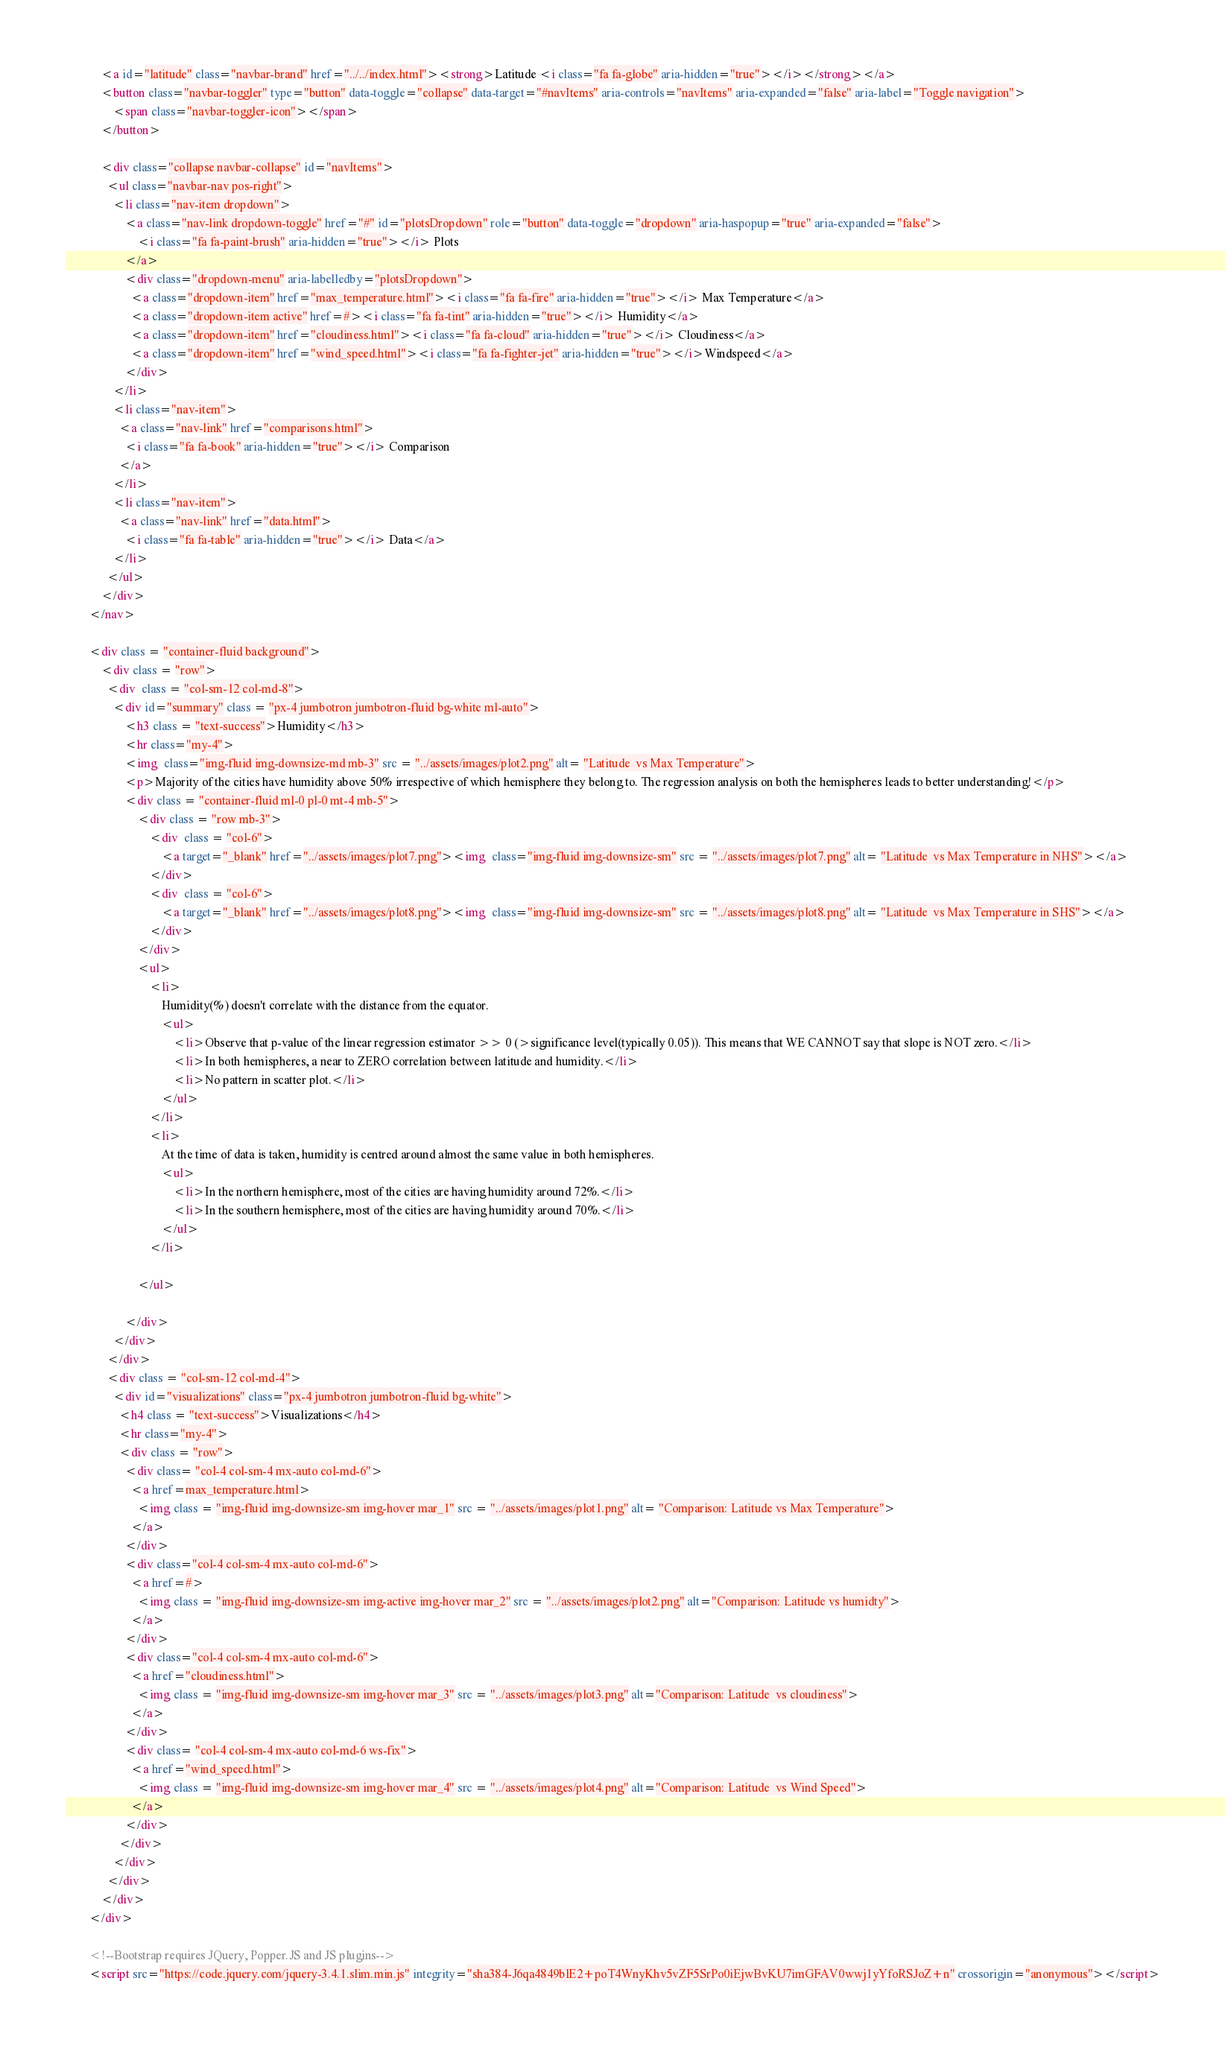<code> <loc_0><loc_0><loc_500><loc_500><_HTML_>            <a id="latitude" class="navbar-brand" href="../../index.html"><strong>Latitude <i class="fa fa-globe" aria-hidden="true"></i></strong></a>
            <button class="navbar-toggler" type="button" data-toggle="collapse" data-target="#navItems" aria-controls="navItems" aria-expanded="false" aria-label="Toggle navigation">
                <span class="navbar-toggler-icon"></span>
            </button>
          
            <div class="collapse navbar-collapse" id="navItems">
              <ul class="navbar-nav pos-right">
                <li class="nav-item dropdown">
                    <a class="nav-link dropdown-toggle" href="#" id="plotsDropdown" role="button" data-toggle="dropdown" aria-haspopup="true" aria-expanded="false">
                        <i class="fa fa-paint-brush" aria-hidden="true"></i> Plots
                    </a>
                    <div class="dropdown-menu" aria-labelledby="plotsDropdown">
                      <a class="dropdown-item" href="max_temperature.html"><i class="fa fa-fire" aria-hidden="true"></i> Max Temperature</a>
                      <a class="dropdown-item active" href=#><i class="fa fa-tint" aria-hidden="true"></i> Humidity</a>
                      <a class="dropdown-item" href="cloudiness.html"><i class="fa fa-cloud" aria-hidden="true"></i> Cloudiness</a>
                      <a class="dropdown-item" href="wind_speed.html"><i class="fa fa-fighter-jet" aria-hidden="true"></i>Windspeed</a>
                    </div>
                </li>
                <li class="nav-item">
                  <a class="nav-link" href="comparisons.html">
                    <i class="fa fa-book" aria-hidden="true"></i> Comparison
                  </a>
                </li>
                <li class="nav-item">
                  <a class="nav-link" href="data.html">
                    <i class="fa fa-table" aria-hidden="true"></i> Data</a>
                </li>
              </ul>
            </div>
        </nav>

        <div class = "container-fluid background">
            <div class = "row">
              <div  class = "col-sm-12 col-md-8">
                <div id="summary" class = "px-4 jumbotron jumbotron-fluid bg-white ml-auto">
                    <h3 class = "text-success">Humidity</h3>
                    <hr class="my-4">
                    <img  class="img-fluid img-downsize-md mb-3" src = "../assets/images/plot2.png" alt= "Latitude  vs Max Temperature"> 
                    <p>Majority of the cities have humidity above 50% irrespective of which hemisphere they belong to. The regression analysis on both the hemispheres leads to better understanding!</p>
                    <div class = "container-fluid ml-0 pl-0 mt-4 mb-5">
                        <div class = "row mb-3">
                            <div  class = "col-6">
                                <a target="_blank" href="../assets/images/plot7.png"><img  class="img-fluid img-downsize-sm" src = "../assets/images/plot7.png" alt= "Latitude  vs Max Temperature in NHS"></a> 
                            </div>
                            <div  class = "col-6">
                                <a target="_blank" href="../assets/images/plot8.png"><img  class="img-fluid img-downsize-sm" src = "../assets/images/plot8.png" alt= "Latitude  vs Max Temperature in SHS"></a>
                            </div>
                        </div>
                        <ul>
                            <li>
                                Humidity(%) doesn't correlate with the distance from the equator. 
                                <ul>
                                    <li>Observe that p-value of the linear regression estimator >> 0 (>significance level(typically 0.05)). This means that WE CANNOT say that slope is NOT zero.</li>
                                    <li>In both hemispheres, a near to ZERO correlation between latitude and humidity.</li>
                                    <li>No pattern in scatter plot.</li>
                                </ul>
                            </li>
                            <li>
                                At the time of data is taken, humidity is centred around almost the same value in both hemispheres.
                                <ul>
                                    <li>In the northern hemisphere, most of the cities are having humidity around 72%.</li>
                                    <li>In the southern hemisphere, most of the cities are having humidity around 70%.</li>
                                </ul>
                            </li>

                        </ul>
                        
                    </div>
                </div>
              </div>
              <div class = "col-sm-12 col-md-4">
                <div id="visualizations" class="px-4 jumbotron jumbotron-fluid bg-white">
                  <h4 class = "text-success">Visualizations</h4>
                  <hr class="my-4">
                  <div class = "row">
                    <div class= "col-4 col-sm-4 mx-auto col-md-6">
                      <a href=max_temperature.html>
                        <img class = "img-fluid img-downsize-sm img-hover mar_1" src = "../assets/images/plot1.png" alt= "Comparison: Latitude vs Max Temperature"> 
                      </a>
                    </div>
                    <div class="col-4 col-sm-4 mx-auto col-md-6">
                      <a href=#>
                        <img class = "img-fluid img-downsize-sm img-active img-hover mar_2" src = "../assets/images/plot2.png" alt="Comparison: Latitude vs humidty">
                      </a>
                    </div>
                    <div class="col-4 col-sm-4 mx-auto col-md-6">
                      <a href="cloudiness.html">
                        <img class = "img-fluid img-downsize-sm img-hover mar_3" src = "../assets/images/plot3.png" alt="Comparison: Latitude  vs cloudiness">  
                      </a>
                    </div>
                    <div class= "col-4 col-sm-4 mx-auto col-md-6 ws-fix">
                      <a href="wind_speed.html">
                        <img class = "img-fluid img-downsize-sm img-hover mar_4" src = "../assets/images/plot4.png" alt="Comparison: Latitude  vs Wind Speed">
                      </a>
                    </div>
                  </div>
                </div>
              </div>
            </div>
        </div>

        <!--Bootstrap requires JQuery, Popper.JS and JS plugins-->
        <script src="https://code.jquery.com/jquery-3.4.1.slim.min.js" integrity="sha384-J6qa4849blE2+poT4WnyKhv5vZF5SrPo0iEjwBvKU7imGFAV0wwj1yYfoRSJoZ+n" crossorigin="anonymous"></script></code> 